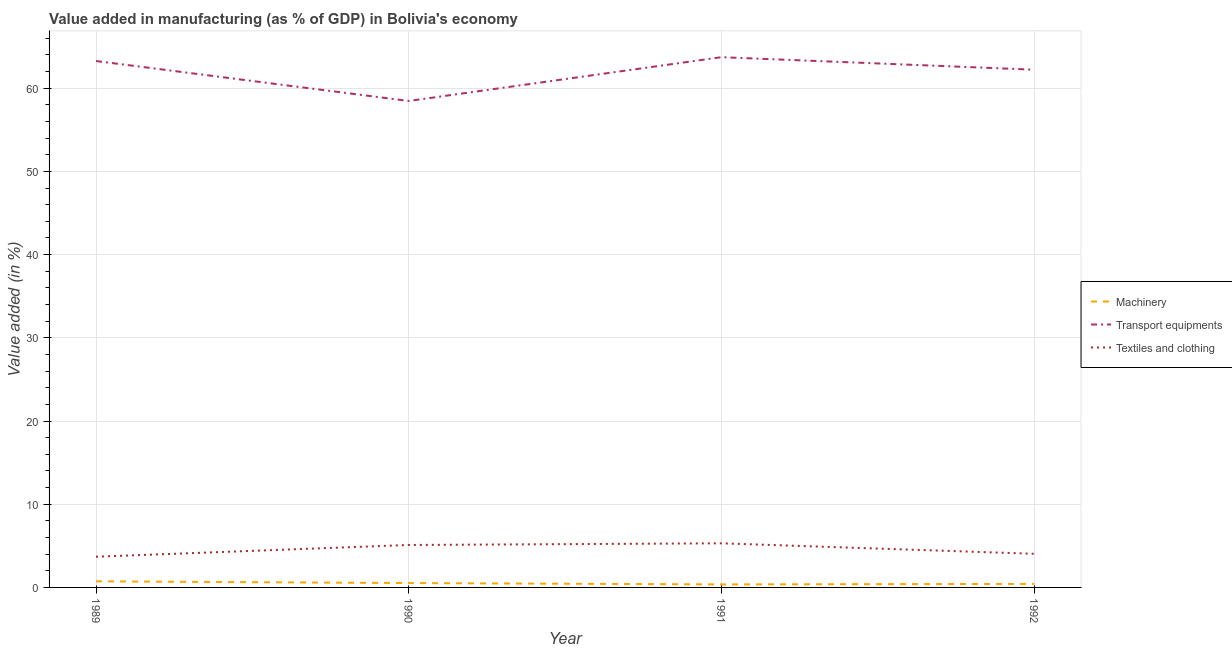Is the number of lines equal to the number of legend labels?
Provide a short and direct response. Yes. What is the value added in manufacturing textile and clothing in 1990?
Make the answer very short. 5.1. Across all years, what is the maximum value added in manufacturing transport equipments?
Offer a very short reply. 63.72. Across all years, what is the minimum value added in manufacturing textile and clothing?
Give a very brief answer. 3.69. What is the total value added in manufacturing transport equipments in the graph?
Your response must be concise. 247.67. What is the difference between the value added in manufacturing transport equipments in 1989 and that in 1992?
Provide a short and direct response. 1.04. What is the difference between the value added in manufacturing transport equipments in 1989 and the value added in manufacturing textile and clothing in 1991?
Offer a very short reply. 57.96. What is the average value added in manufacturing machinery per year?
Your answer should be compact. 0.51. In the year 1992, what is the difference between the value added in manufacturing textile and clothing and value added in manufacturing transport equipments?
Offer a terse response. -58.18. In how many years, is the value added in manufacturing textile and clothing greater than 60 %?
Offer a very short reply. 0. What is the ratio of the value added in manufacturing machinery in 1990 to that in 1992?
Your answer should be very brief. 1.24. Is the value added in manufacturing transport equipments in 1989 less than that in 1990?
Make the answer very short. No. Is the difference between the value added in manufacturing textile and clothing in 1989 and 1992 greater than the difference between the value added in manufacturing machinery in 1989 and 1992?
Make the answer very short. No. What is the difference between the highest and the second highest value added in manufacturing textile and clothing?
Provide a short and direct response. 0.2. What is the difference between the highest and the lowest value added in manufacturing transport equipments?
Give a very brief answer. 5.26. In how many years, is the value added in manufacturing machinery greater than the average value added in manufacturing machinery taken over all years?
Provide a succinct answer. 2. Is the sum of the value added in manufacturing machinery in 1989 and 1991 greater than the maximum value added in manufacturing textile and clothing across all years?
Provide a succinct answer. No. Are the values on the major ticks of Y-axis written in scientific E-notation?
Keep it short and to the point. No. Does the graph contain any zero values?
Your answer should be compact. No. Does the graph contain grids?
Your response must be concise. Yes. Where does the legend appear in the graph?
Your response must be concise. Center right. How many legend labels are there?
Your response must be concise. 3. What is the title of the graph?
Offer a terse response. Value added in manufacturing (as % of GDP) in Bolivia's economy. What is the label or title of the Y-axis?
Give a very brief answer. Value added (in %). What is the Value added (in %) of Machinery in 1989?
Your answer should be compact. 0.73. What is the Value added (in %) of Transport equipments in 1989?
Make the answer very short. 63.26. What is the Value added (in %) in Textiles and clothing in 1989?
Make the answer very short. 3.69. What is the Value added (in %) in Machinery in 1990?
Offer a terse response. 0.53. What is the Value added (in %) of Transport equipments in 1990?
Keep it short and to the point. 58.46. What is the Value added (in %) in Textiles and clothing in 1990?
Your response must be concise. 5.1. What is the Value added (in %) in Machinery in 1991?
Your answer should be compact. 0.36. What is the Value added (in %) in Transport equipments in 1991?
Offer a terse response. 63.72. What is the Value added (in %) in Textiles and clothing in 1991?
Your response must be concise. 5.3. What is the Value added (in %) of Machinery in 1992?
Your answer should be very brief. 0.42. What is the Value added (in %) in Transport equipments in 1992?
Offer a terse response. 62.22. What is the Value added (in %) of Textiles and clothing in 1992?
Your response must be concise. 4.04. Across all years, what is the maximum Value added (in %) of Machinery?
Give a very brief answer. 0.73. Across all years, what is the maximum Value added (in %) of Transport equipments?
Ensure brevity in your answer.  63.72. Across all years, what is the maximum Value added (in %) in Textiles and clothing?
Your answer should be compact. 5.3. Across all years, what is the minimum Value added (in %) in Machinery?
Provide a succinct answer. 0.36. Across all years, what is the minimum Value added (in %) of Transport equipments?
Make the answer very short. 58.46. Across all years, what is the minimum Value added (in %) in Textiles and clothing?
Ensure brevity in your answer.  3.69. What is the total Value added (in %) in Machinery in the graph?
Your answer should be compact. 2.05. What is the total Value added (in %) in Transport equipments in the graph?
Provide a succinct answer. 247.67. What is the total Value added (in %) in Textiles and clothing in the graph?
Your response must be concise. 18.14. What is the difference between the Value added (in %) of Machinery in 1989 and that in 1990?
Offer a very short reply. 0.21. What is the difference between the Value added (in %) in Transport equipments in 1989 and that in 1990?
Give a very brief answer. 4.8. What is the difference between the Value added (in %) in Textiles and clothing in 1989 and that in 1990?
Ensure brevity in your answer.  -1.41. What is the difference between the Value added (in %) of Machinery in 1989 and that in 1991?
Your response must be concise. 0.37. What is the difference between the Value added (in %) in Transport equipments in 1989 and that in 1991?
Give a very brief answer. -0.46. What is the difference between the Value added (in %) of Textiles and clothing in 1989 and that in 1991?
Offer a very short reply. -1.61. What is the difference between the Value added (in %) in Machinery in 1989 and that in 1992?
Make the answer very short. 0.31. What is the difference between the Value added (in %) of Transport equipments in 1989 and that in 1992?
Your response must be concise. 1.04. What is the difference between the Value added (in %) of Textiles and clothing in 1989 and that in 1992?
Offer a terse response. -0.35. What is the difference between the Value added (in %) in Machinery in 1990 and that in 1991?
Give a very brief answer. 0.16. What is the difference between the Value added (in %) in Transport equipments in 1990 and that in 1991?
Your response must be concise. -5.26. What is the difference between the Value added (in %) in Textiles and clothing in 1990 and that in 1991?
Your answer should be compact. -0.2. What is the difference between the Value added (in %) in Machinery in 1990 and that in 1992?
Provide a short and direct response. 0.1. What is the difference between the Value added (in %) of Transport equipments in 1990 and that in 1992?
Offer a terse response. -3.76. What is the difference between the Value added (in %) in Textiles and clothing in 1990 and that in 1992?
Provide a short and direct response. 1.06. What is the difference between the Value added (in %) in Machinery in 1991 and that in 1992?
Your response must be concise. -0.06. What is the difference between the Value added (in %) of Transport equipments in 1991 and that in 1992?
Make the answer very short. 1.5. What is the difference between the Value added (in %) in Textiles and clothing in 1991 and that in 1992?
Ensure brevity in your answer.  1.26. What is the difference between the Value added (in %) in Machinery in 1989 and the Value added (in %) in Transport equipments in 1990?
Provide a short and direct response. -57.73. What is the difference between the Value added (in %) in Machinery in 1989 and the Value added (in %) in Textiles and clothing in 1990?
Ensure brevity in your answer.  -4.37. What is the difference between the Value added (in %) in Transport equipments in 1989 and the Value added (in %) in Textiles and clothing in 1990?
Give a very brief answer. 58.16. What is the difference between the Value added (in %) in Machinery in 1989 and the Value added (in %) in Transport equipments in 1991?
Keep it short and to the point. -62.99. What is the difference between the Value added (in %) of Machinery in 1989 and the Value added (in %) of Textiles and clothing in 1991?
Keep it short and to the point. -4.57. What is the difference between the Value added (in %) in Transport equipments in 1989 and the Value added (in %) in Textiles and clothing in 1991?
Make the answer very short. 57.96. What is the difference between the Value added (in %) in Machinery in 1989 and the Value added (in %) in Transport equipments in 1992?
Give a very brief answer. -61.49. What is the difference between the Value added (in %) of Machinery in 1989 and the Value added (in %) of Textiles and clothing in 1992?
Your response must be concise. -3.31. What is the difference between the Value added (in %) in Transport equipments in 1989 and the Value added (in %) in Textiles and clothing in 1992?
Your answer should be compact. 59.22. What is the difference between the Value added (in %) of Machinery in 1990 and the Value added (in %) of Transport equipments in 1991?
Provide a succinct answer. -63.2. What is the difference between the Value added (in %) of Machinery in 1990 and the Value added (in %) of Textiles and clothing in 1991?
Your answer should be very brief. -4.78. What is the difference between the Value added (in %) of Transport equipments in 1990 and the Value added (in %) of Textiles and clothing in 1991?
Your answer should be very brief. 53.16. What is the difference between the Value added (in %) in Machinery in 1990 and the Value added (in %) in Transport equipments in 1992?
Your answer should be very brief. -61.7. What is the difference between the Value added (in %) of Machinery in 1990 and the Value added (in %) of Textiles and clothing in 1992?
Your response must be concise. -3.52. What is the difference between the Value added (in %) of Transport equipments in 1990 and the Value added (in %) of Textiles and clothing in 1992?
Make the answer very short. 54.42. What is the difference between the Value added (in %) in Machinery in 1991 and the Value added (in %) in Transport equipments in 1992?
Ensure brevity in your answer.  -61.86. What is the difference between the Value added (in %) of Machinery in 1991 and the Value added (in %) of Textiles and clothing in 1992?
Your response must be concise. -3.68. What is the difference between the Value added (in %) in Transport equipments in 1991 and the Value added (in %) in Textiles and clothing in 1992?
Keep it short and to the point. 59.68. What is the average Value added (in %) in Machinery per year?
Your answer should be very brief. 0.51. What is the average Value added (in %) in Transport equipments per year?
Make the answer very short. 61.92. What is the average Value added (in %) of Textiles and clothing per year?
Offer a terse response. 4.53. In the year 1989, what is the difference between the Value added (in %) of Machinery and Value added (in %) of Transport equipments?
Your answer should be very brief. -62.53. In the year 1989, what is the difference between the Value added (in %) in Machinery and Value added (in %) in Textiles and clothing?
Provide a short and direct response. -2.96. In the year 1989, what is the difference between the Value added (in %) in Transport equipments and Value added (in %) in Textiles and clothing?
Give a very brief answer. 59.57. In the year 1990, what is the difference between the Value added (in %) of Machinery and Value added (in %) of Transport equipments?
Give a very brief answer. -57.94. In the year 1990, what is the difference between the Value added (in %) of Machinery and Value added (in %) of Textiles and clothing?
Your answer should be compact. -4.58. In the year 1990, what is the difference between the Value added (in %) of Transport equipments and Value added (in %) of Textiles and clothing?
Make the answer very short. 53.36. In the year 1991, what is the difference between the Value added (in %) of Machinery and Value added (in %) of Transport equipments?
Make the answer very short. -63.36. In the year 1991, what is the difference between the Value added (in %) of Machinery and Value added (in %) of Textiles and clothing?
Your response must be concise. -4.94. In the year 1991, what is the difference between the Value added (in %) of Transport equipments and Value added (in %) of Textiles and clothing?
Your answer should be compact. 58.42. In the year 1992, what is the difference between the Value added (in %) in Machinery and Value added (in %) in Transport equipments?
Offer a terse response. -61.8. In the year 1992, what is the difference between the Value added (in %) in Machinery and Value added (in %) in Textiles and clothing?
Ensure brevity in your answer.  -3.62. In the year 1992, what is the difference between the Value added (in %) in Transport equipments and Value added (in %) in Textiles and clothing?
Your answer should be compact. 58.18. What is the ratio of the Value added (in %) in Machinery in 1989 to that in 1990?
Your response must be concise. 1.4. What is the ratio of the Value added (in %) of Transport equipments in 1989 to that in 1990?
Ensure brevity in your answer.  1.08. What is the ratio of the Value added (in %) in Textiles and clothing in 1989 to that in 1990?
Make the answer very short. 0.72. What is the ratio of the Value added (in %) in Machinery in 1989 to that in 1991?
Provide a short and direct response. 2.03. What is the ratio of the Value added (in %) of Transport equipments in 1989 to that in 1991?
Provide a short and direct response. 0.99. What is the ratio of the Value added (in %) of Textiles and clothing in 1989 to that in 1991?
Give a very brief answer. 0.7. What is the ratio of the Value added (in %) in Machinery in 1989 to that in 1992?
Give a very brief answer. 1.74. What is the ratio of the Value added (in %) in Transport equipments in 1989 to that in 1992?
Offer a terse response. 1.02. What is the ratio of the Value added (in %) of Textiles and clothing in 1989 to that in 1992?
Keep it short and to the point. 0.91. What is the ratio of the Value added (in %) of Machinery in 1990 to that in 1991?
Keep it short and to the point. 1.45. What is the ratio of the Value added (in %) of Transport equipments in 1990 to that in 1991?
Your response must be concise. 0.92. What is the ratio of the Value added (in %) in Textiles and clothing in 1990 to that in 1991?
Offer a terse response. 0.96. What is the ratio of the Value added (in %) in Machinery in 1990 to that in 1992?
Ensure brevity in your answer.  1.24. What is the ratio of the Value added (in %) of Transport equipments in 1990 to that in 1992?
Your answer should be very brief. 0.94. What is the ratio of the Value added (in %) of Textiles and clothing in 1990 to that in 1992?
Provide a short and direct response. 1.26. What is the ratio of the Value added (in %) of Machinery in 1991 to that in 1992?
Keep it short and to the point. 0.86. What is the ratio of the Value added (in %) in Transport equipments in 1991 to that in 1992?
Your response must be concise. 1.02. What is the ratio of the Value added (in %) in Textiles and clothing in 1991 to that in 1992?
Keep it short and to the point. 1.31. What is the difference between the highest and the second highest Value added (in %) of Machinery?
Ensure brevity in your answer.  0.21. What is the difference between the highest and the second highest Value added (in %) of Transport equipments?
Offer a very short reply. 0.46. What is the difference between the highest and the second highest Value added (in %) in Textiles and clothing?
Provide a succinct answer. 0.2. What is the difference between the highest and the lowest Value added (in %) in Machinery?
Ensure brevity in your answer.  0.37. What is the difference between the highest and the lowest Value added (in %) of Transport equipments?
Your answer should be compact. 5.26. What is the difference between the highest and the lowest Value added (in %) in Textiles and clothing?
Offer a very short reply. 1.61. 